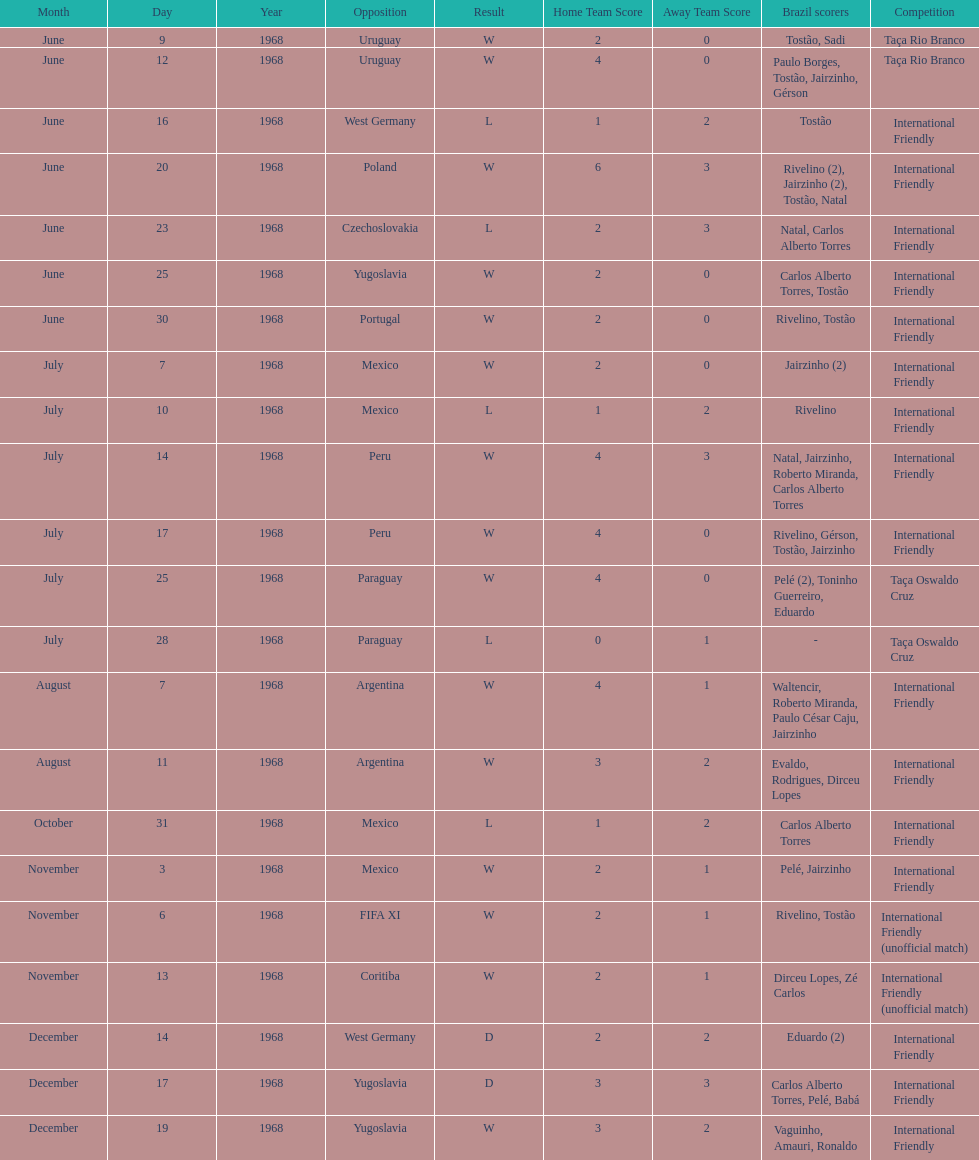Total number of wins 15. 